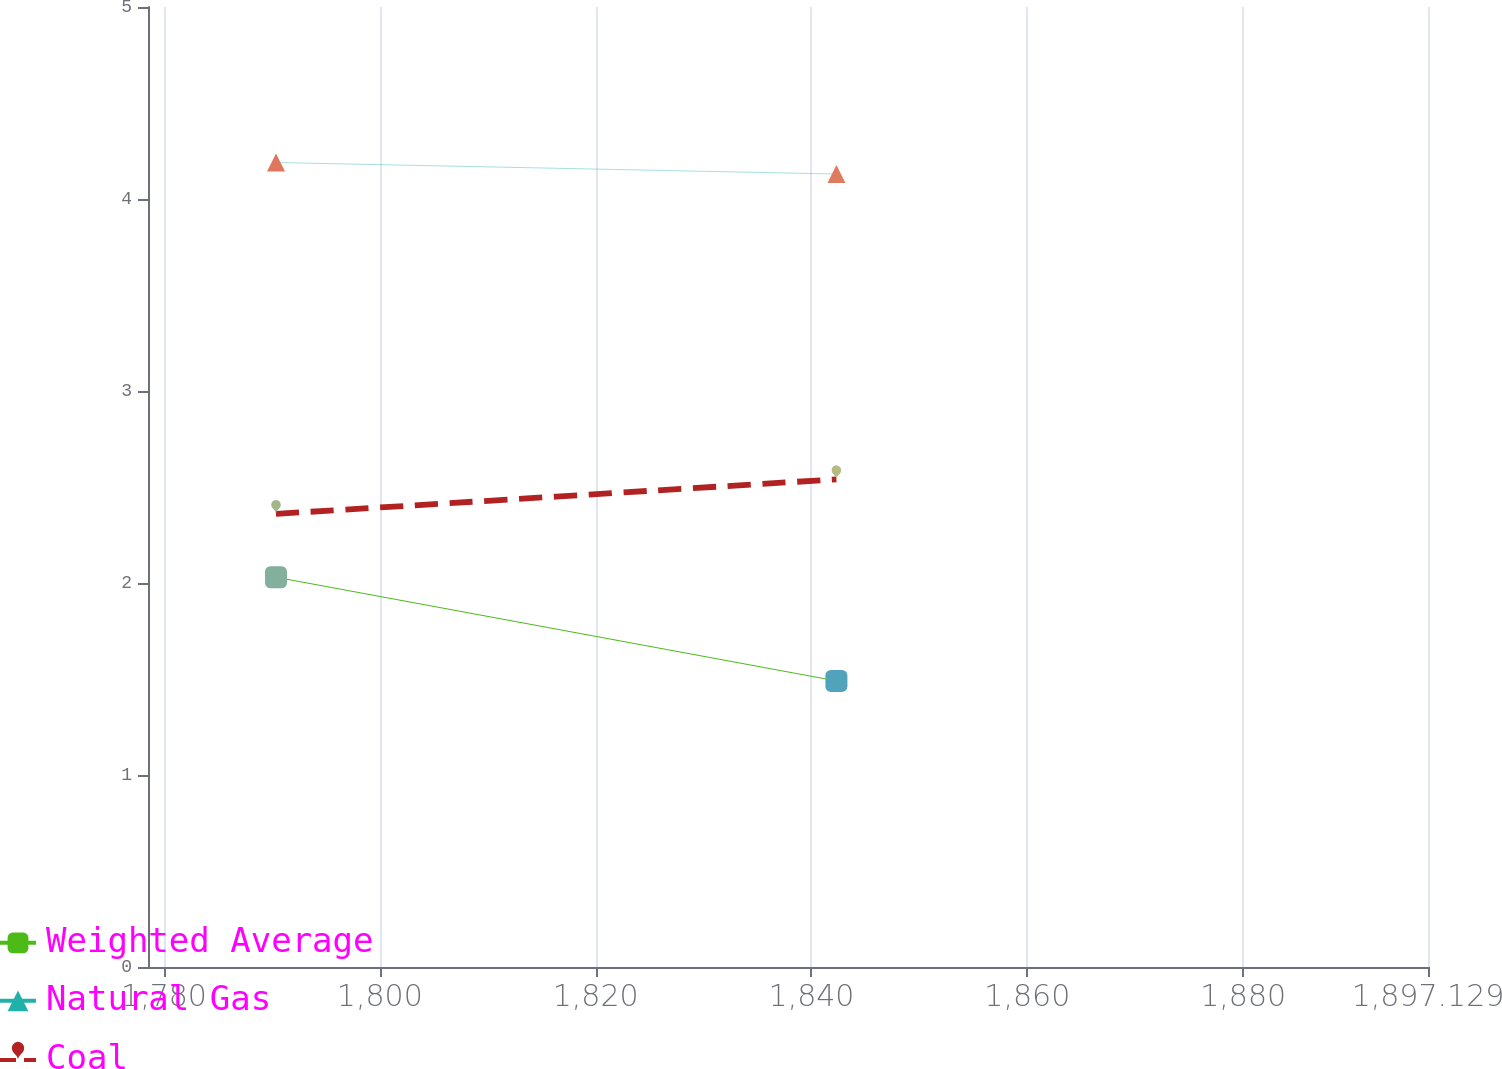<chart> <loc_0><loc_0><loc_500><loc_500><line_chart><ecel><fcel>Weighted Average<fcel>Natural Gas<fcel>Coal<nl><fcel>1790.38<fcel>2.03<fcel>4.19<fcel>2.36<nl><fcel>1842.31<fcel>1.49<fcel>4.13<fcel>2.54<nl><fcel>1908.99<fcel>1.66<fcel>4.74<fcel>2.52<nl></chart> 